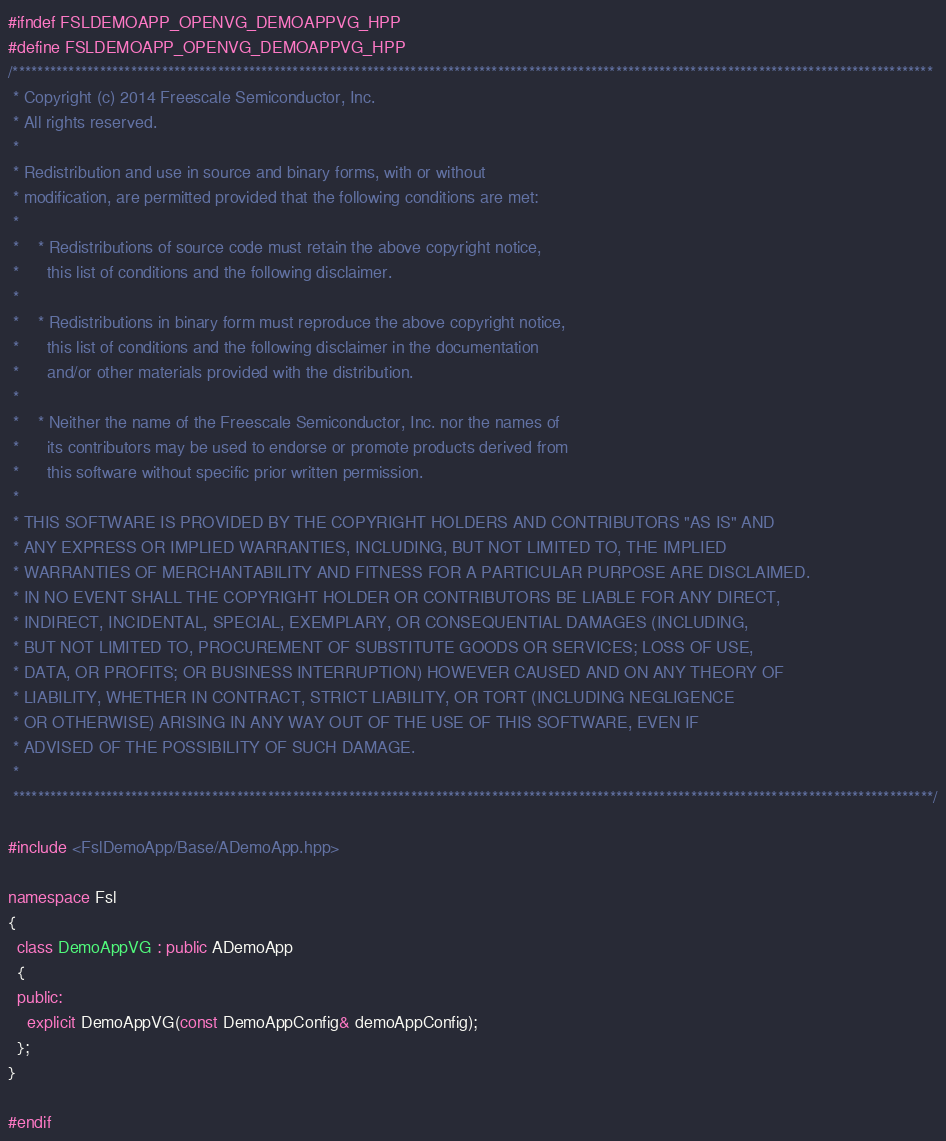<code> <loc_0><loc_0><loc_500><loc_500><_C++_>#ifndef FSLDEMOAPP_OPENVG_DEMOAPPVG_HPP
#define FSLDEMOAPP_OPENVG_DEMOAPPVG_HPP
/****************************************************************************************************************************************************
 * Copyright (c) 2014 Freescale Semiconductor, Inc.
 * All rights reserved.
 *
 * Redistribution and use in source and binary forms, with or without
 * modification, are permitted provided that the following conditions are met:
 *
 *    * Redistributions of source code must retain the above copyright notice,
 *      this list of conditions and the following disclaimer.
 *
 *    * Redistributions in binary form must reproduce the above copyright notice,
 *      this list of conditions and the following disclaimer in the documentation
 *      and/or other materials provided with the distribution.
 *
 *    * Neither the name of the Freescale Semiconductor, Inc. nor the names of
 *      its contributors may be used to endorse or promote products derived from
 *      this software without specific prior written permission.
 *
 * THIS SOFTWARE IS PROVIDED BY THE COPYRIGHT HOLDERS AND CONTRIBUTORS "AS IS" AND
 * ANY EXPRESS OR IMPLIED WARRANTIES, INCLUDING, BUT NOT LIMITED TO, THE IMPLIED
 * WARRANTIES OF MERCHANTABILITY AND FITNESS FOR A PARTICULAR PURPOSE ARE DISCLAIMED.
 * IN NO EVENT SHALL THE COPYRIGHT HOLDER OR CONTRIBUTORS BE LIABLE FOR ANY DIRECT,
 * INDIRECT, INCIDENTAL, SPECIAL, EXEMPLARY, OR CONSEQUENTIAL DAMAGES (INCLUDING,
 * BUT NOT LIMITED TO, PROCUREMENT OF SUBSTITUTE GOODS OR SERVICES; LOSS OF USE,
 * DATA, OR PROFITS; OR BUSINESS INTERRUPTION) HOWEVER CAUSED AND ON ANY THEORY OF
 * LIABILITY, WHETHER IN CONTRACT, STRICT LIABILITY, OR TORT (INCLUDING NEGLIGENCE
 * OR OTHERWISE) ARISING IN ANY WAY OUT OF THE USE OF THIS SOFTWARE, EVEN IF
 * ADVISED OF THE POSSIBILITY OF SUCH DAMAGE.
 *
 ****************************************************************************************************************************************************/

#include <FslDemoApp/Base/ADemoApp.hpp>

namespace Fsl
{
  class DemoAppVG : public ADemoApp
  {
  public:
    explicit DemoAppVG(const DemoAppConfig& demoAppConfig);
  };
}

#endif
</code> 